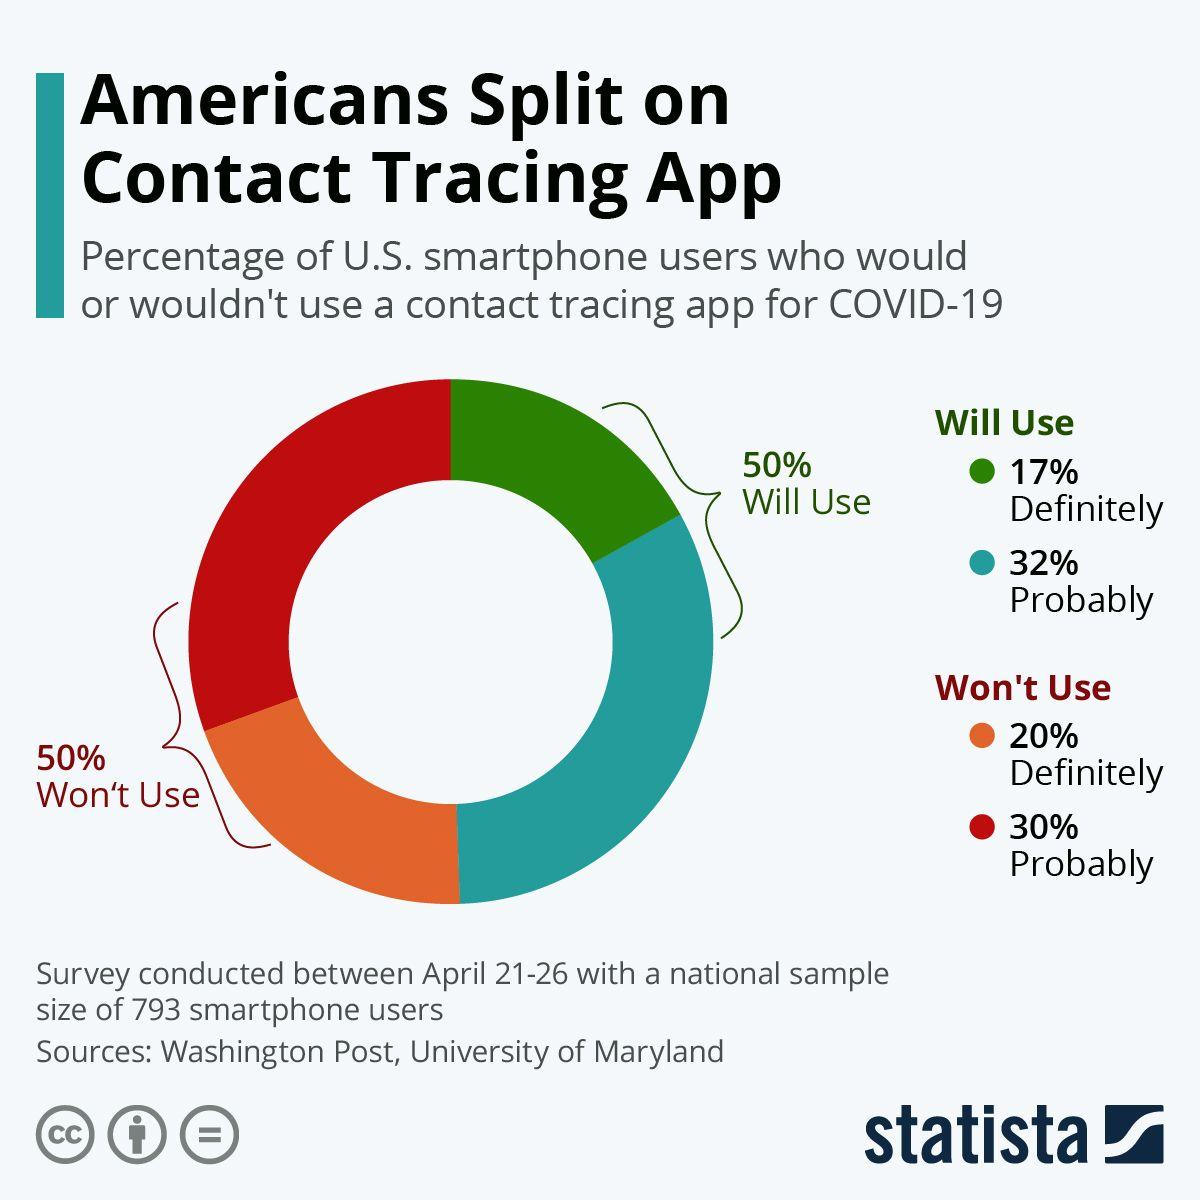Identify some key points in this picture. According to a survey, 17% of U.S. smartphone users stated that they definitely would use a contact tracing app for COVID-19. According to a survey, 32% of U.S. smartphone users are likely to use a contact tracing app for COVID-19. According to a survey, approximately 30% of U.S. smartphone users are unlikely to use a contact tracing app for COVID-19. According to a survey, 20% of U.S. smartphone users indicated that they will definitely not use a contact tracing app for COVID-19. 